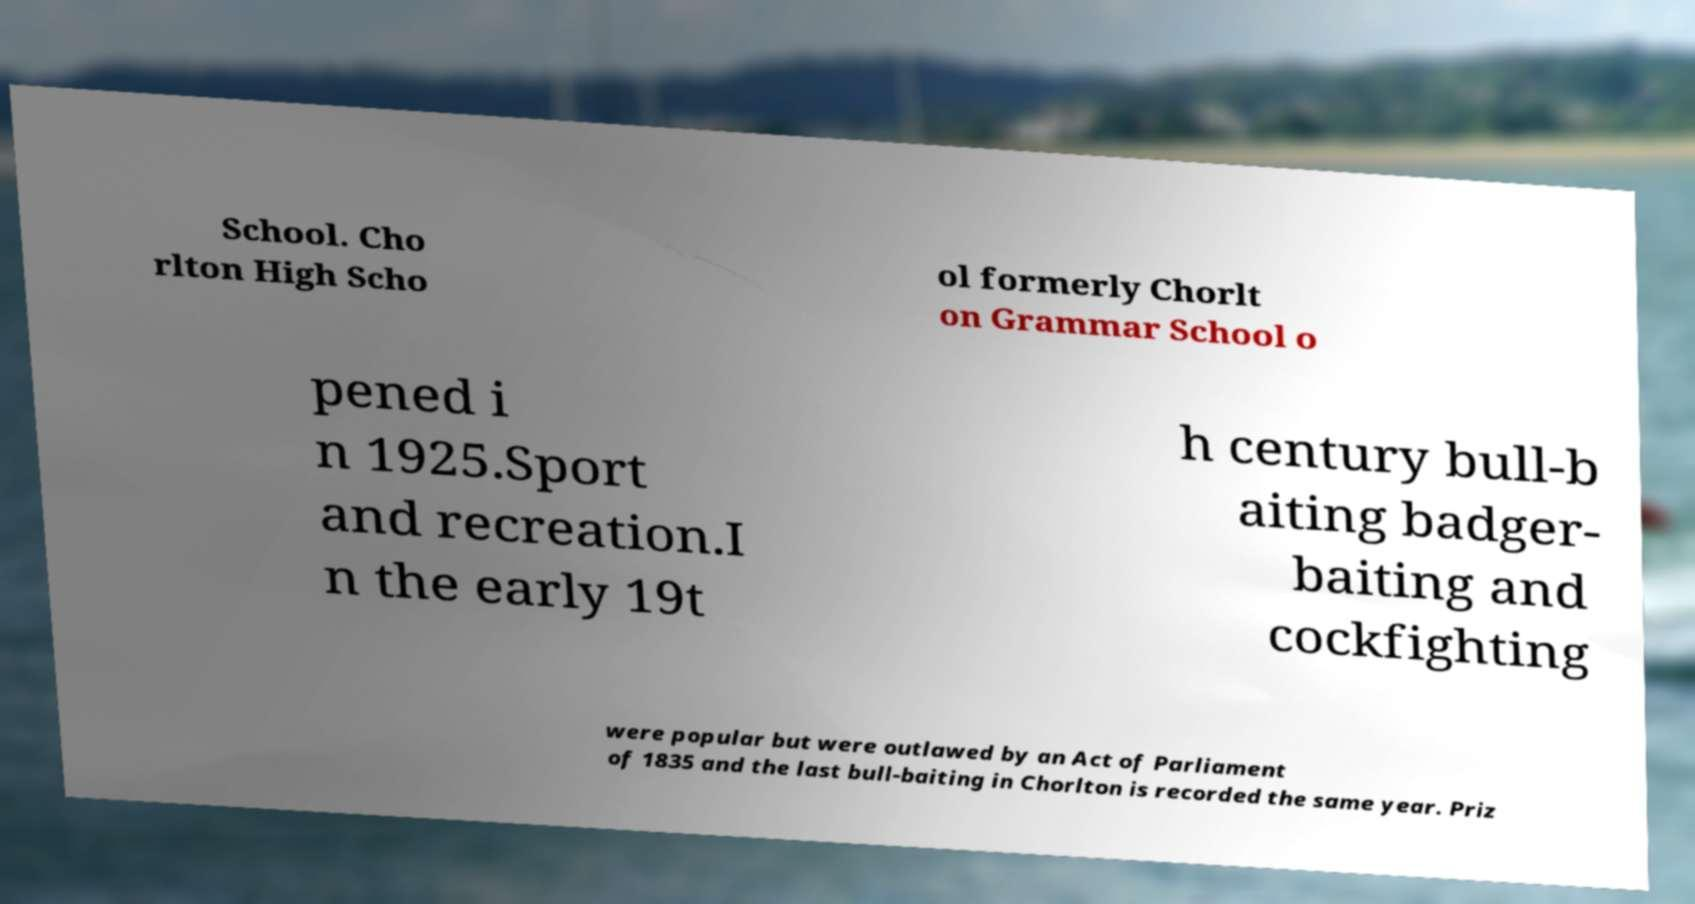There's text embedded in this image that I need extracted. Can you transcribe it verbatim? School. Cho rlton High Scho ol formerly Chorlt on Grammar School o pened i n 1925.Sport and recreation.I n the early 19t h century bull-b aiting badger- baiting and cockfighting were popular but were outlawed by an Act of Parliament of 1835 and the last bull-baiting in Chorlton is recorded the same year. Priz 